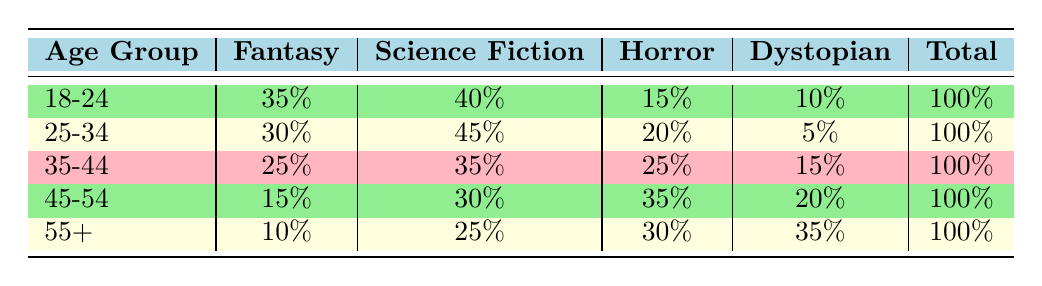What genre do the 18-24 age group prefer the most? The table shows that the 18-24 age group has the highest preference for Science Fiction, with 40%.
Answer: Science Fiction Which age group has the lowest preference for Fantasy? From the table, the 55+ age group has the lowest preference for Fantasy, with only 10%.
Answer: 55+ What is the total percentage preference for Horror among the 35-44 and 45-54 age groups? For the 35-44 age group, the preference for Horror is 25%, and for the 45-54 age group, it is 35%. Adding these gives 25 + 35 = 60%.
Answer: 60% Is the preference for Dystopian fiction highest among the 25-34 age group? The table indicates that the 25-34 age group has a Dystopian preference of 5%, which is lower than that of the 55+ age group at 35%. Hence, it is false.
Answer: No Which age group shows an equal interest in Fantasy and Horror combined? The 35-44 age group has a combined preference of 25% for Fantasy and 25% for Horror, giving a total of 50%. This matches the 18-24 age group where Fantasy is 35% and Horror is 15%, totaling 50% as well.
Answer: 35-44 and 18-24 What is the difference in preference for Science Fiction between the 25-34 and 45-54 age groups? The preference for Science Fiction in the 25-34 age group is 45%, and in the 45-54 group, it is 30%. The difference is 45 - 30 = 15%.
Answer: 15% Among all age groups, which genre has the highest cumulative percentage preference? To find the cumulative percentage, we add up the percentages for each genre across all age groups. For Fantasy: 35 + 30 + 25 + 15 + 10 = 115%, Science Fiction: 40 + 45 + 35 + 30 + 25 = 175%, Horror: 15 + 20 + 25 + 35 + 30 = 115%, and Dystopian: 10 + 5 + 15 + 20 + 35 = 85%. The highest is for Science Fiction at 175%.
Answer: Science Fiction 